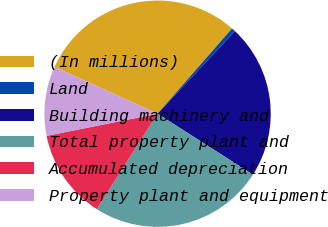Convert chart to OTSL. <chart><loc_0><loc_0><loc_500><loc_500><pie_chart><fcel>(In millions)<fcel>Land<fcel>Building machinery and<fcel>Total property plant and<fcel>Accumulated depreciation<fcel>Property plant and equipment<nl><fcel>29.65%<fcel>0.56%<fcel>22.07%<fcel>24.98%<fcel>12.83%<fcel>9.92%<nl></chart> 